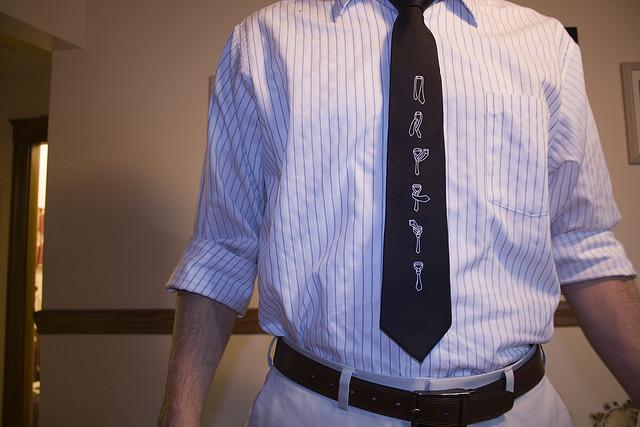The pictograms on the tie show how to do what? tie tie 